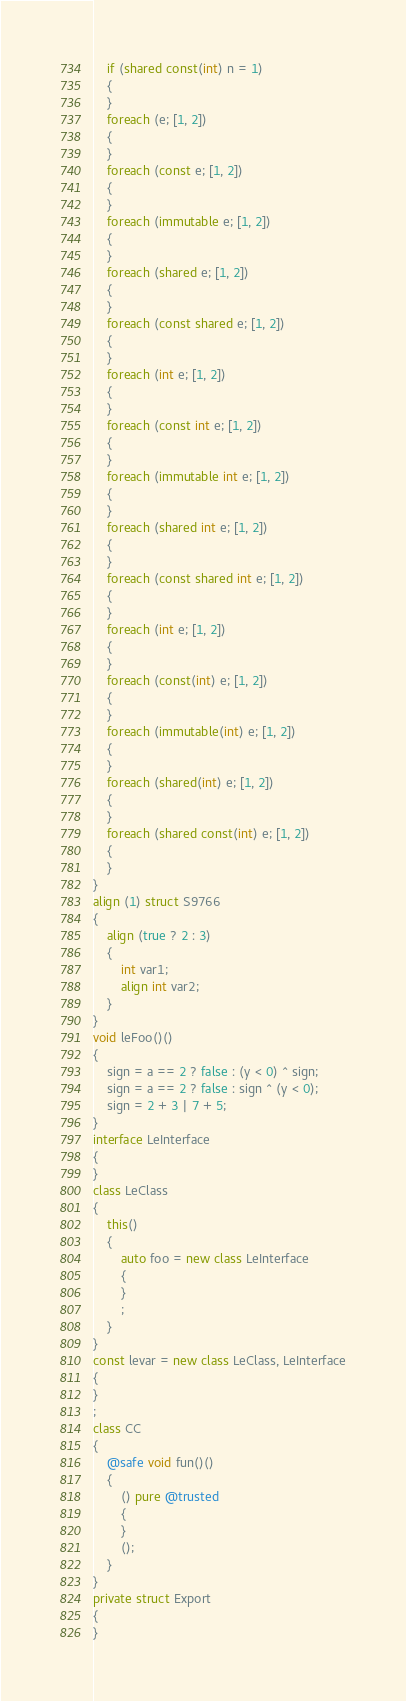<code> <loc_0><loc_0><loc_500><loc_500><_D_>	if (shared const(int) n = 1)
	{
	}
	foreach (e; [1, 2])
	{
	}
	foreach (const e; [1, 2])
	{
	}
	foreach (immutable e; [1, 2])
	{
	}
	foreach (shared e; [1, 2])
	{
	}
	foreach (const shared e; [1, 2])
	{
	}
	foreach (int e; [1, 2])
	{
	}
	foreach (const int e; [1, 2])
	{
	}
	foreach (immutable int e; [1, 2])
	{
	}
	foreach (shared int e; [1, 2])
	{
	}
	foreach (const shared int e; [1, 2])
	{
	}
	foreach (int e; [1, 2])
	{
	}
	foreach (const(int) e; [1, 2])
	{
	}
	foreach (immutable(int) e; [1, 2])
	{
	}
	foreach (shared(int) e; [1, 2])
	{
	}
	foreach (shared const(int) e; [1, 2])
	{
	}
}
align (1) struct S9766
{
	align (true ? 2 : 3) 
	{
		int var1;
		align int var2;
	}
}
void leFoo()()
{
	sign = a == 2 ? false : (y < 0) ^ sign;
	sign = a == 2 ? false : sign ^ (y < 0);
	sign = 2 + 3 | 7 + 5;
}
interface LeInterface
{
}
class LeClass
{
	this()
	{
		auto foo = new class LeInterface
		{
		}
		;
	}
}
const levar = new class LeClass, LeInterface
{
}
;
class CC
{
	@safe void fun()()
	{
		() pure @trusted
		{
		}
		();
	}
}
private struct Export
{
}
</code> 